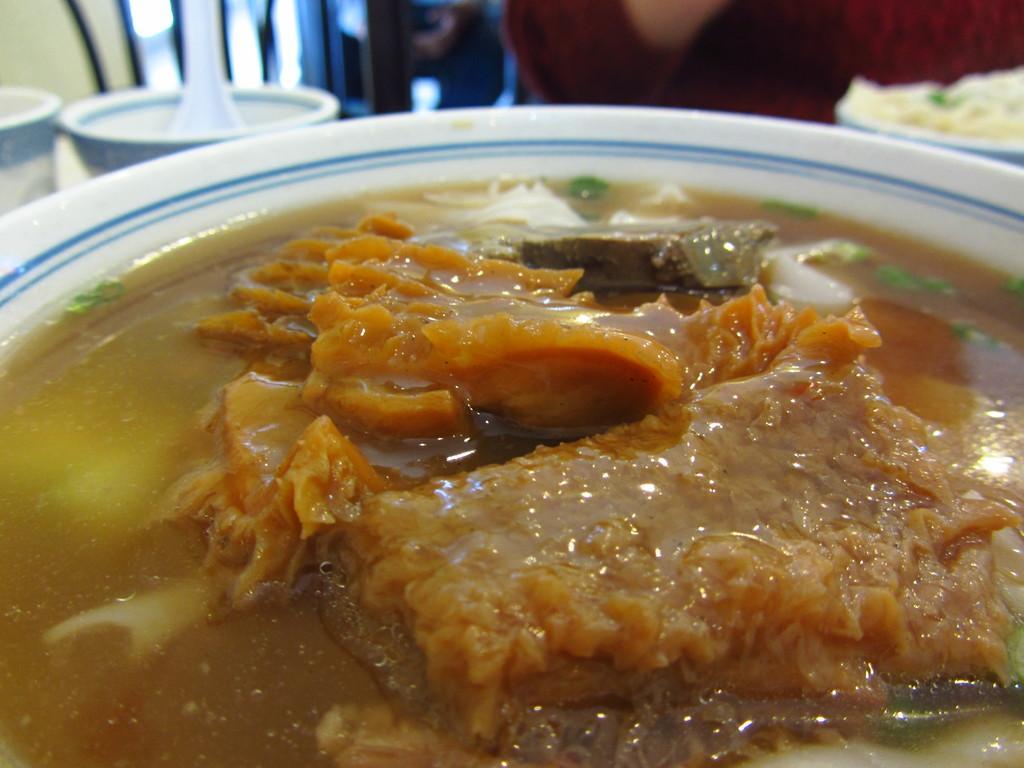In one or two sentences, can you explain what this image depicts? In this image there is a bowl truncated, there is food in the bowl, there is a spoon truncated, there is a bowl truncated towards the left of the image, there is a bowl truncated towards the right of the image, there is a person truncated. 